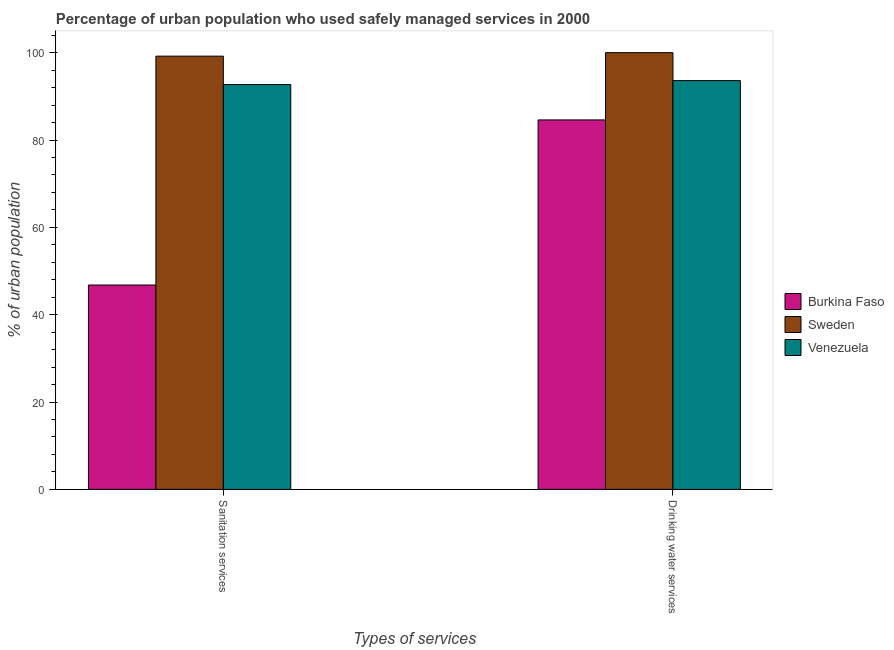How many different coloured bars are there?
Make the answer very short. 3. How many bars are there on the 1st tick from the left?
Make the answer very short. 3. How many bars are there on the 1st tick from the right?
Provide a succinct answer. 3. What is the label of the 2nd group of bars from the left?
Your answer should be compact. Drinking water services. What is the percentage of urban population who used sanitation services in Venezuela?
Provide a short and direct response. 92.7. Across all countries, what is the maximum percentage of urban population who used sanitation services?
Your answer should be compact. 99.2. Across all countries, what is the minimum percentage of urban population who used drinking water services?
Make the answer very short. 84.6. In which country was the percentage of urban population who used drinking water services minimum?
Provide a short and direct response. Burkina Faso. What is the total percentage of urban population who used drinking water services in the graph?
Your answer should be compact. 278.2. What is the difference between the percentage of urban population who used sanitation services in Burkina Faso and the percentage of urban population who used drinking water services in Venezuela?
Keep it short and to the point. -46.8. What is the average percentage of urban population who used drinking water services per country?
Provide a short and direct response. 92.73. What is the difference between the percentage of urban population who used drinking water services and percentage of urban population who used sanitation services in Burkina Faso?
Make the answer very short. 37.8. What is the ratio of the percentage of urban population who used drinking water services in Sweden to that in Burkina Faso?
Provide a succinct answer. 1.18. What does the 1st bar from the left in Sanitation services represents?
Provide a short and direct response. Burkina Faso. What does the 2nd bar from the right in Drinking water services represents?
Give a very brief answer. Sweden. How many bars are there?
Your answer should be compact. 6. How many countries are there in the graph?
Provide a short and direct response. 3. Does the graph contain grids?
Provide a short and direct response. No. How many legend labels are there?
Offer a terse response. 3. How are the legend labels stacked?
Your answer should be very brief. Vertical. What is the title of the graph?
Give a very brief answer. Percentage of urban population who used safely managed services in 2000. Does "Togo" appear as one of the legend labels in the graph?
Your answer should be very brief. No. What is the label or title of the X-axis?
Ensure brevity in your answer.  Types of services. What is the label or title of the Y-axis?
Offer a terse response. % of urban population. What is the % of urban population of Burkina Faso in Sanitation services?
Your answer should be compact. 46.8. What is the % of urban population of Sweden in Sanitation services?
Give a very brief answer. 99.2. What is the % of urban population of Venezuela in Sanitation services?
Your response must be concise. 92.7. What is the % of urban population of Burkina Faso in Drinking water services?
Your answer should be very brief. 84.6. What is the % of urban population of Venezuela in Drinking water services?
Provide a succinct answer. 93.6. Across all Types of services, what is the maximum % of urban population of Burkina Faso?
Provide a short and direct response. 84.6. Across all Types of services, what is the maximum % of urban population of Venezuela?
Offer a terse response. 93.6. Across all Types of services, what is the minimum % of urban population in Burkina Faso?
Your answer should be compact. 46.8. Across all Types of services, what is the minimum % of urban population in Sweden?
Your response must be concise. 99.2. Across all Types of services, what is the minimum % of urban population in Venezuela?
Provide a short and direct response. 92.7. What is the total % of urban population in Burkina Faso in the graph?
Your answer should be very brief. 131.4. What is the total % of urban population in Sweden in the graph?
Offer a terse response. 199.2. What is the total % of urban population of Venezuela in the graph?
Ensure brevity in your answer.  186.3. What is the difference between the % of urban population of Burkina Faso in Sanitation services and that in Drinking water services?
Keep it short and to the point. -37.8. What is the difference between the % of urban population in Venezuela in Sanitation services and that in Drinking water services?
Provide a short and direct response. -0.9. What is the difference between the % of urban population of Burkina Faso in Sanitation services and the % of urban population of Sweden in Drinking water services?
Provide a short and direct response. -53.2. What is the difference between the % of urban population in Burkina Faso in Sanitation services and the % of urban population in Venezuela in Drinking water services?
Give a very brief answer. -46.8. What is the average % of urban population of Burkina Faso per Types of services?
Keep it short and to the point. 65.7. What is the average % of urban population in Sweden per Types of services?
Your response must be concise. 99.6. What is the average % of urban population of Venezuela per Types of services?
Ensure brevity in your answer.  93.15. What is the difference between the % of urban population in Burkina Faso and % of urban population in Sweden in Sanitation services?
Your response must be concise. -52.4. What is the difference between the % of urban population of Burkina Faso and % of urban population of Venezuela in Sanitation services?
Ensure brevity in your answer.  -45.9. What is the difference between the % of urban population of Burkina Faso and % of urban population of Sweden in Drinking water services?
Your answer should be compact. -15.4. What is the difference between the % of urban population in Burkina Faso and % of urban population in Venezuela in Drinking water services?
Provide a short and direct response. -9. What is the difference between the % of urban population in Sweden and % of urban population in Venezuela in Drinking water services?
Give a very brief answer. 6.4. What is the ratio of the % of urban population in Burkina Faso in Sanitation services to that in Drinking water services?
Your response must be concise. 0.55. What is the ratio of the % of urban population of Venezuela in Sanitation services to that in Drinking water services?
Provide a short and direct response. 0.99. What is the difference between the highest and the second highest % of urban population of Burkina Faso?
Your response must be concise. 37.8. What is the difference between the highest and the second highest % of urban population in Sweden?
Offer a very short reply. 0.8. What is the difference between the highest and the lowest % of urban population of Burkina Faso?
Your answer should be very brief. 37.8. 